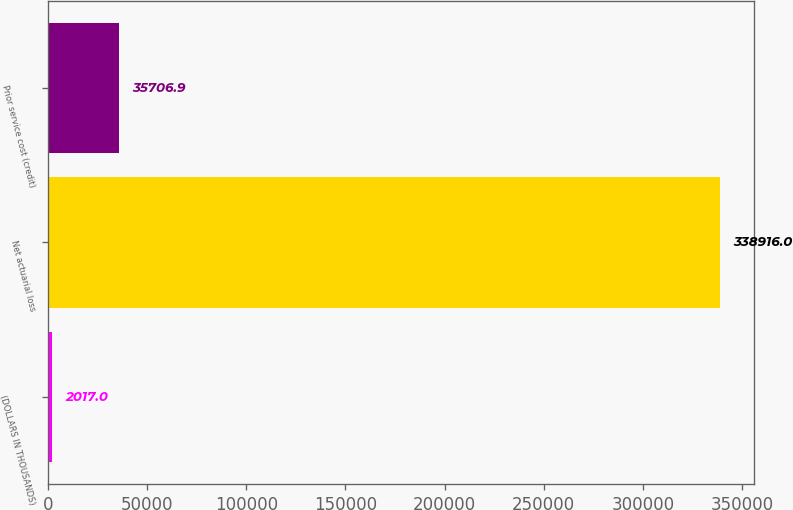Convert chart. <chart><loc_0><loc_0><loc_500><loc_500><bar_chart><fcel>(DOLLARS IN THOUSANDS)<fcel>Net actuarial loss<fcel>Prior service cost (credit)<nl><fcel>2017<fcel>338916<fcel>35706.9<nl></chart> 